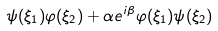<formula> <loc_0><loc_0><loc_500><loc_500>\psi ( \xi _ { 1 } ) \varphi ( \xi _ { 2 } ) + \alpha e ^ { i \beta } \varphi ( \xi _ { 1 } ) \psi ( \xi _ { 2 } )</formula> 